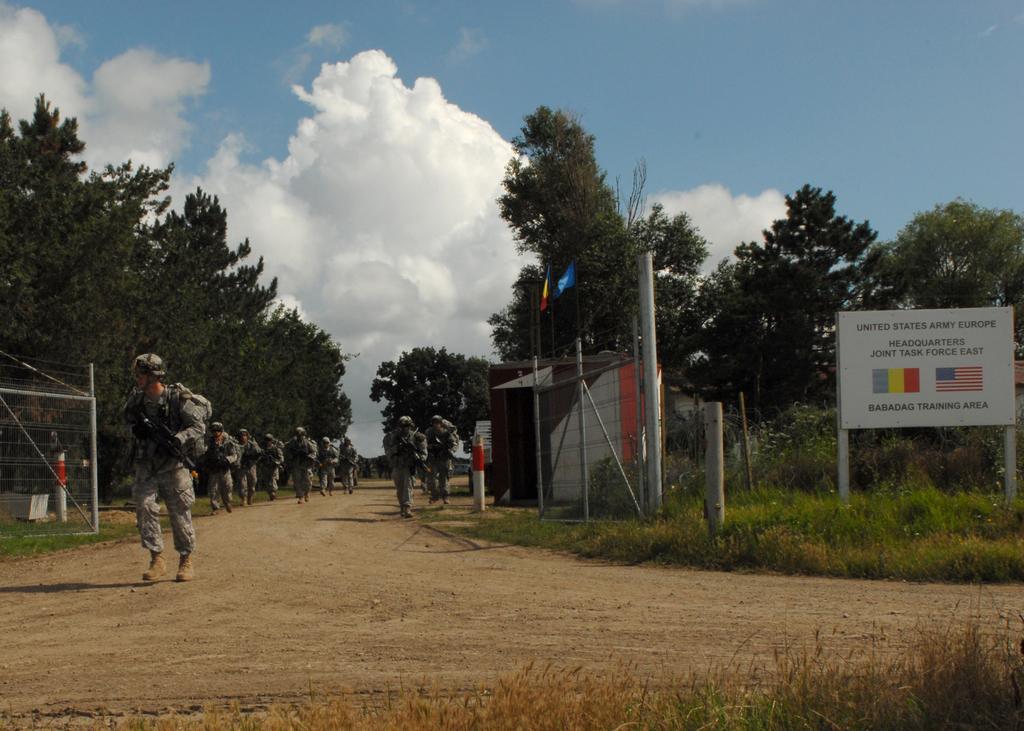Please provide a concise description of this image. This image is clicked on the road. There are many people running on the road. On the either sides of the road there are trees and grass on the ground. To the right there is a board. There is text on the board. At the top there is the sky. In the center there is a cabin beside the road. 